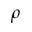Convert formula to latex. <formula><loc_0><loc_0><loc_500><loc_500>\rho</formula> 